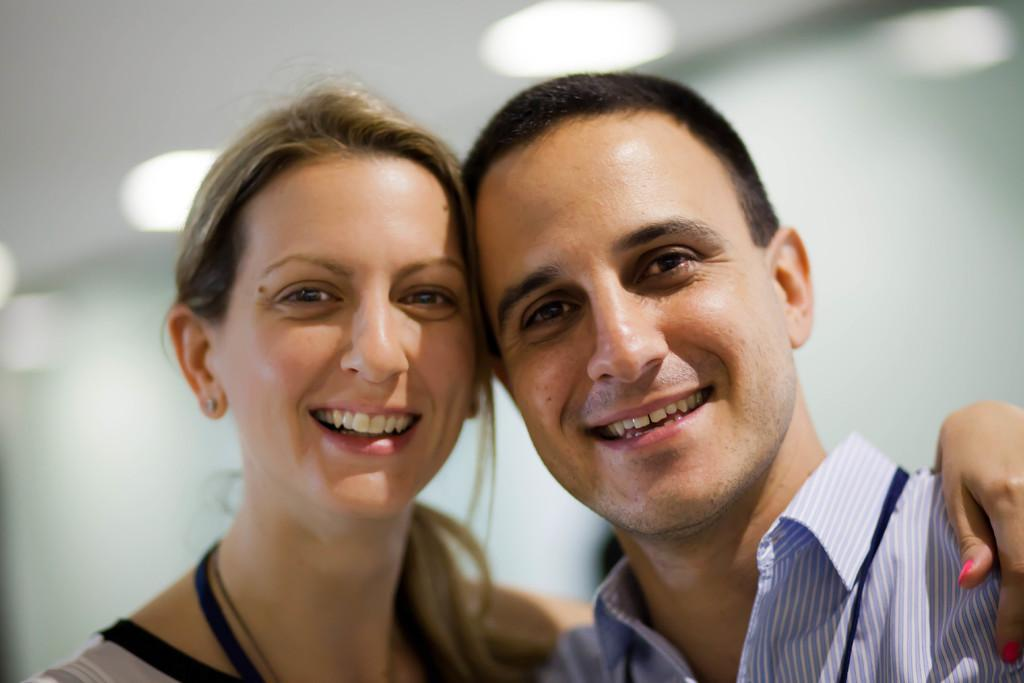How many people are in the image? There are two people in the image. What expressions do the people have? The people are smiling. Can you describe the background of the image? The background of the image is blurry. What type of pot is visible in the image? There is no pot present in the image. What disease can be seen affecting the people in the image? There is no indication of any disease affecting the people in the image; they are smiling. 